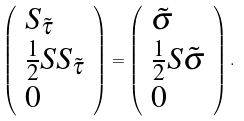Convert formula to latex. <formula><loc_0><loc_0><loc_500><loc_500>\left ( \begin{array} { l } S _ { \tilde { \tau } } \\ \frac { 1 } { 2 } S S _ { \tilde { \tau } } \\ 0 \end{array} \right ) = \left ( \begin{array} { l } \tilde { \sigma } \\ \frac { 1 } { 2 } S \tilde { \sigma } \\ 0 \end{array} \right ) .</formula> 